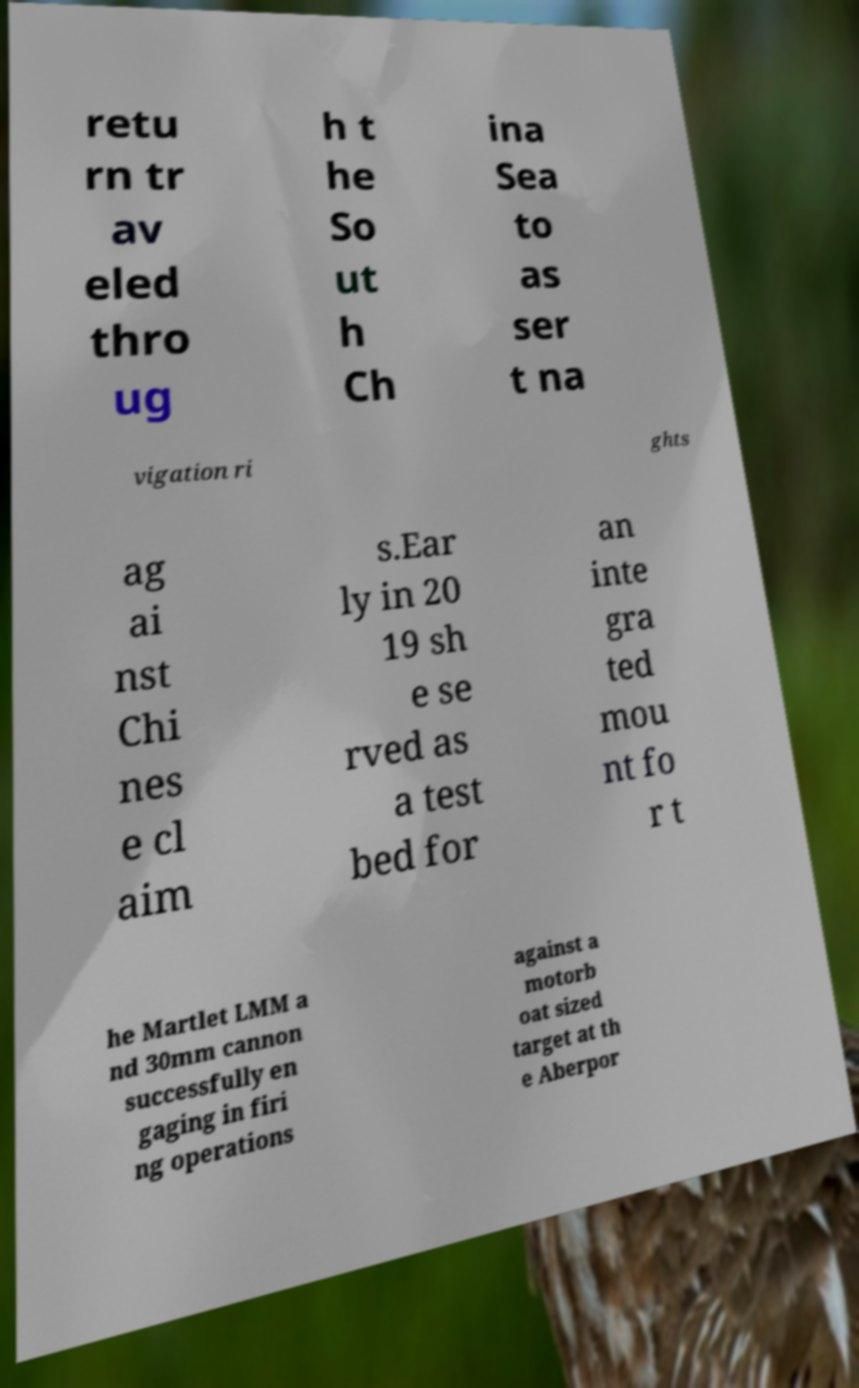There's text embedded in this image that I need extracted. Can you transcribe it verbatim? retu rn tr av eled thro ug h t he So ut h Ch ina Sea to as ser t na vigation ri ghts ag ai nst Chi nes e cl aim s.Ear ly in 20 19 sh e se rved as a test bed for an inte gra ted mou nt fo r t he Martlet LMM a nd 30mm cannon successfully en gaging in firi ng operations against a motorb oat sized target at th e Aberpor 